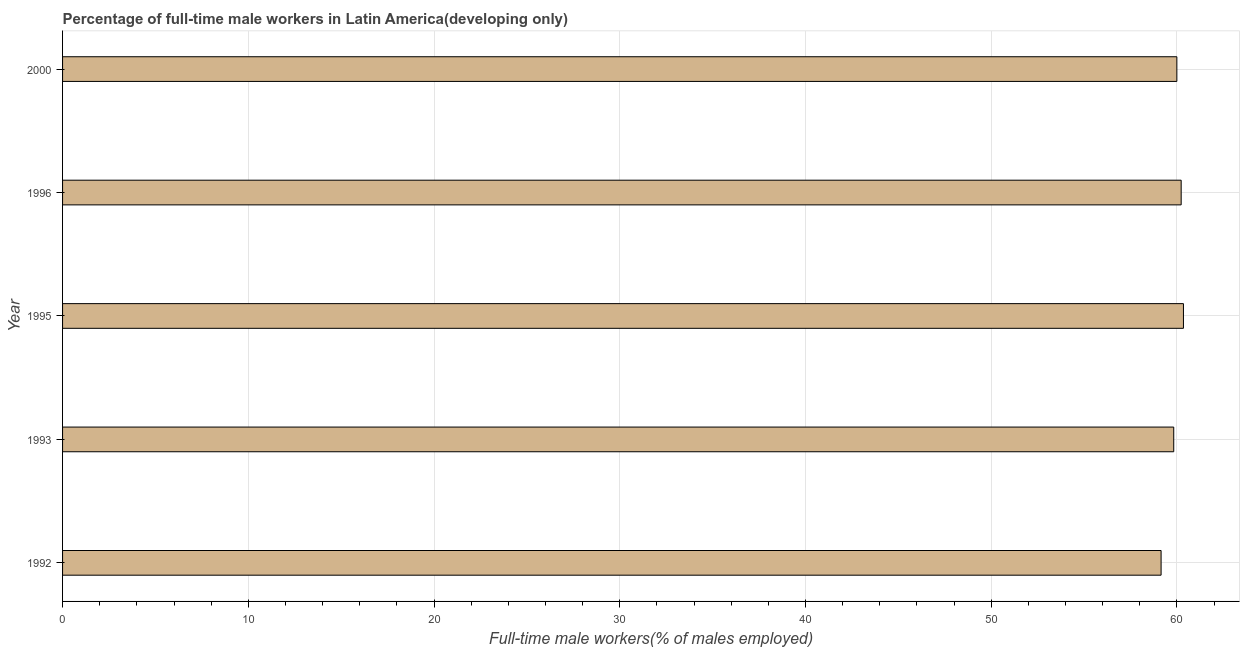What is the title of the graph?
Keep it short and to the point. Percentage of full-time male workers in Latin America(developing only). What is the label or title of the X-axis?
Offer a terse response. Full-time male workers(% of males employed). What is the label or title of the Y-axis?
Make the answer very short. Year. What is the percentage of full-time male workers in 1996?
Your answer should be very brief. 60.23. Across all years, what is the maximum percentage of full-time male workers?
Your answer should be very brief. 60.35. Across all years, what is the minimum percentage of full-time male workers?
Make the answer very short. 59.15. What is the sum of the percentage of full-time male workers?
Give a very brief answer. 299.57. What is the difference between the percentage of full-time male workers in 1992 and 1995?
Ensure brevity in your answer.  -1.2. What is the average percentage of full-time male workers per year?
Ensure brevity in your answer.  59.91. What is the median percentage of full-time male workers?
Your answer should be very brief. 60. In how many years, is the percentage of full-time male workers greater than 34 %?
Provide a succinct answer. 5. Do a majority of the years between 2000 and 1996 (inclusive) have percentage of full-time male workers greater than 26 %?
Offer a terse response. No. What is the difference between the highest and the second highest percentage of full-time male workers?
Your answer should be compact. 0.12. In how many years, is the percentage of full-time male workers greater than the average percentage of full-time male workers taken over all years?
Your response must be concise. 3. How many bars are there?
Your response must be concise. 5. How many years are there in the graph?
Provide a succinct answer. 5. What is the difference between two consecutive major ticks on the X-axis?
Your answer should be compact. 10. What is the Full-time male workers(% of males employed) of 1992?
Make the answer very short. 59.15. What is the Full-time male workers(% of males employed) of 1993?
Provide a short and direct response. 59.83. What is the Full-time male workers(% of males employed) in 1995?
Provide a succinct answer. 60.35. What is the Full-time male workers(% of males employed) in 1996?
Keep it short and to the point. 60.23. What is the Full-time male workers(% of males employed) of 2000?
Your response must be concise. 60. What is the difference between the Full-time male workers(% of males employed) in 1992 and 1993?
Keep it short and to the point. -0.68. What is the difference between the Full-time male workers(% of males employed) in 1992 and 1995?
Your answer should be compact. -1.2. What is the difference between the Full-time male workers(% of males employed) in 1992 and 1996?
Provide a short and direct response. -1.08. What is the difference between the Full-time male workers(% of males employed) in 1992 and 2000?
Keep it short and to the point. -0.85. What is the difference between the Full-time male workers(% of males employed) in 1993 and 1995?
Give a very brief answer. -0.52. What is the difference between the Full-time male workers(% of males employed) in 1993 and 1996?
Ensure brevity in your answer.  -0.4. What is the difference between the Full-time male workers(% of males employed) in 1993 and 2000?
Provide a succinct answer. -0.17. What is the difference between the Full-time male workers(% of males employed) in 1995 and 1996?
Provide a short and direct response. 0.12. What is the difference between the Full-time male workers(% of males employed) in 1995 and 2000?
Provide a succinct answer. 0.35. What is the difference between the Full-time male workers(% of males employed) in 1996 and 2000?
Your response must be concise. 0.23. What is the ratio of the Full-time male workers(% of males employed) in 1992 to that in 1993?
Make the answer very short. 0.99. What is the ratio of the Full-time male workers(% of males employed) in 1993 to that in 1995?
Offer a very short reply. 0.99. What is the ratio of the Full-time male workers(% of males employed) in 1993 to that in 2000?
Your answer should be very brief. 1. What is the ratio of the Full-time male workers(% of males employed) in 1995 to that in 1996?
Make the answer very short. 1. What is the ratio of the Full-time male workers(% of males employed) in 1995 to that in 2000?
Your answer should be very brief. 1.01. 